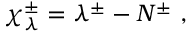Convert formula to latex. <formula><loc_0><loc_0><loc_500><loc_500>{ \chi } _ { \lambda } ^ { \pm } = \lambda ^ { \pm } - N ^ { \pm } ,</formula> 